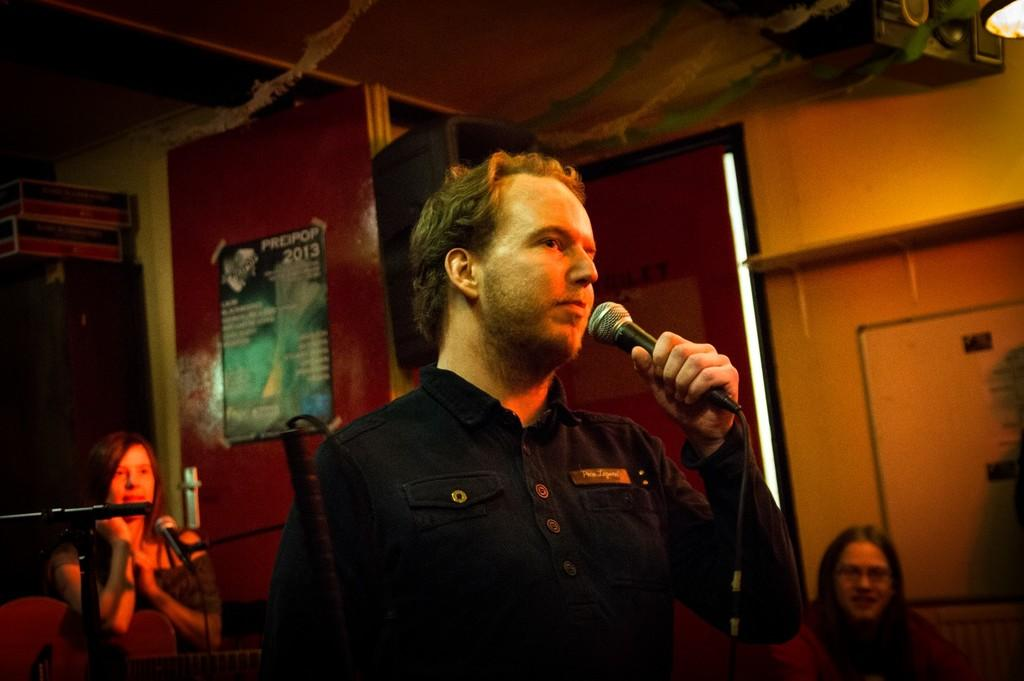What is the man in the image holding? The man is holding a mic. How many women are present in the background of the image? There are 2 women in the background of the image. What can be seen in the background of the image besides the women? There is a wall visible in the background of the image. What type of sign is the man holding in the image? The man is not holding a sign in the image; he is holding a mic. What type of skin condition can be seen on the women in the image? There is no indication of any skin condition on the women in the image. 